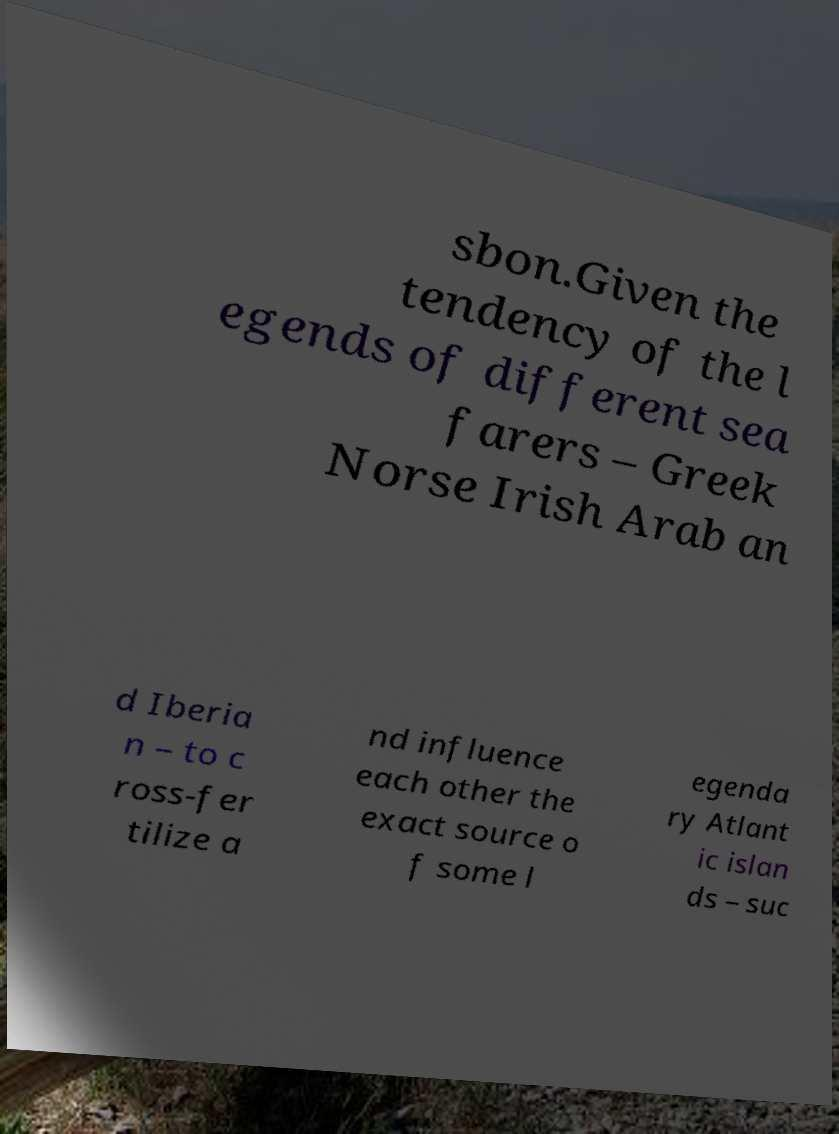Please identify and transcribe the text found in this image. sbon.Given the tendency of the l egends of different sea farers – Greek Norse Irish Arab an d Iberia n – to c ross-fer tilize a nd influence each other the exact source o f some l egenda ry Atlant ic islan ds – suc 